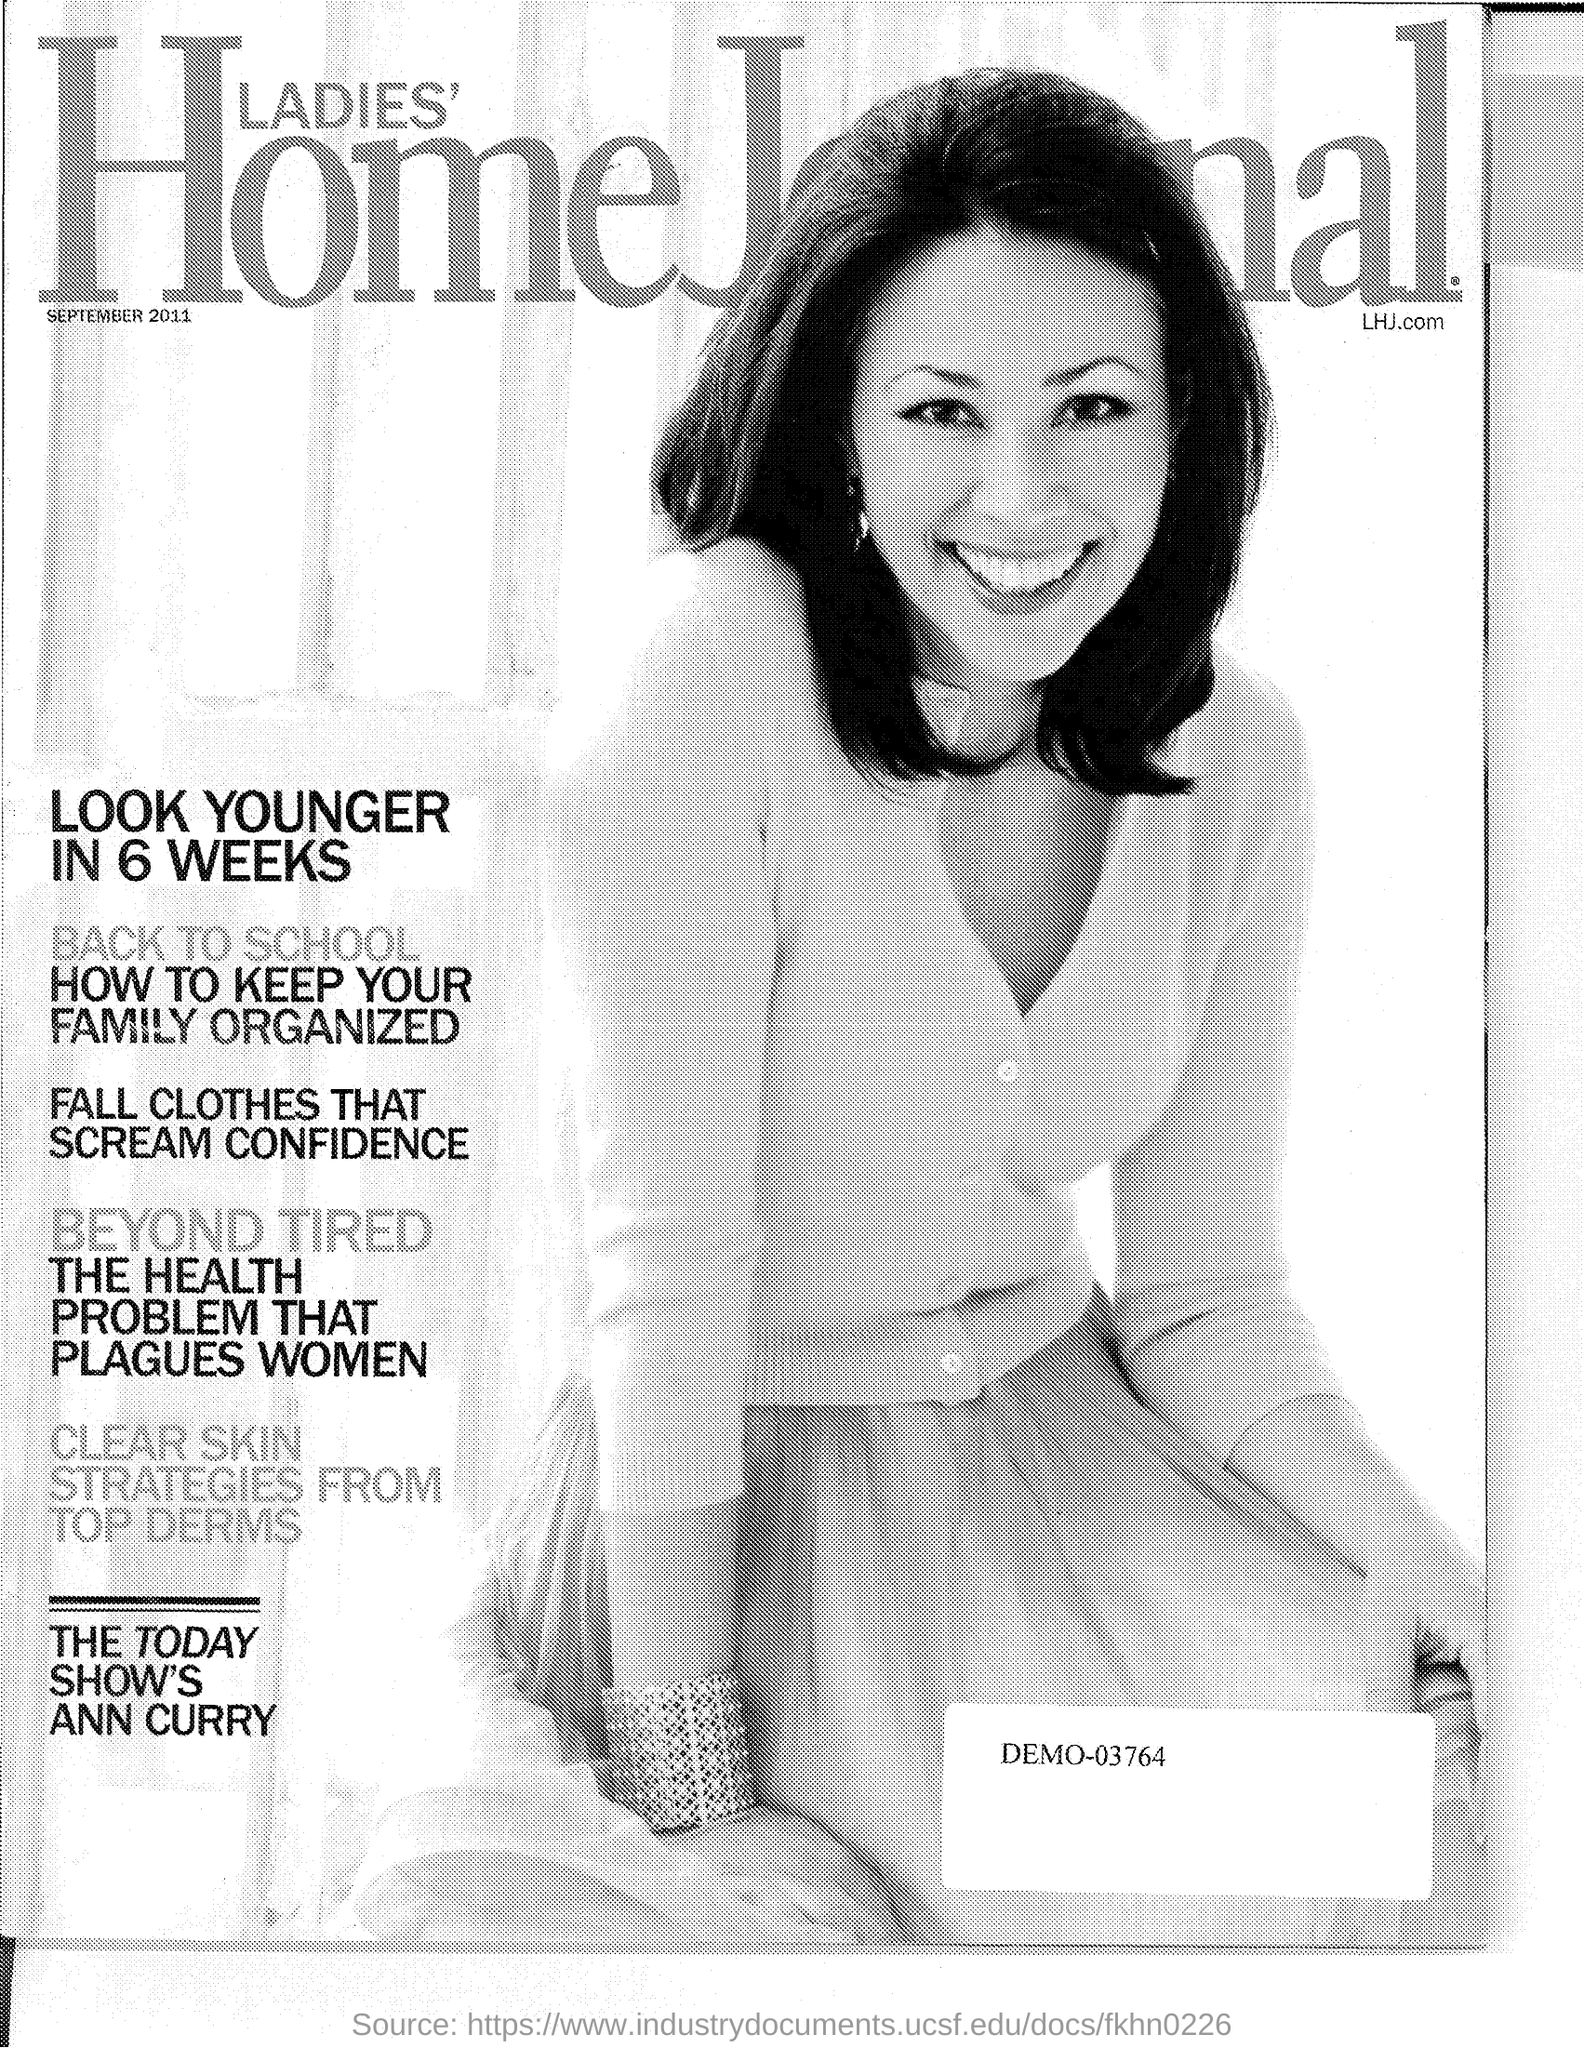Mention a couple of crucial points in this snapshot. The year mentioned in the document is September 2011. 